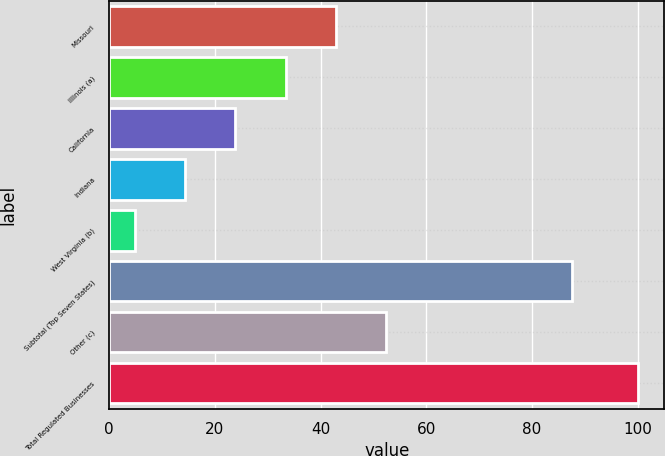Convert chart to OTSL. <chart><loc_0><loc_0><loc_500><loc_500><bar_chart><fcel>Missouri<fcel>Illinois (a)<fcel>California<fcel>Indiana<fcel>West Virginia (b)<fcel>Subtotal (Top Seven States)<fcel>Other (c)<fcel>Total Regulated Businesses<nl><fcel>42.88<fcel>33.36<fcel>23.84<fcel>14.32<fcel>4.8<fcel>87.5<fcel>52.4<fcel>100<nl></chart> 